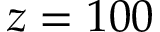Convert formula to latex. <formula><loc_0><loc_0><loc_500><loc_500>z = 1 0 0</formula> 